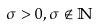Convert formula to latex. <formula><loc_0><loc_0><loc_500><loc_500>\sigma > 0 , \sigma \notin \mathbb { N }</formula> 